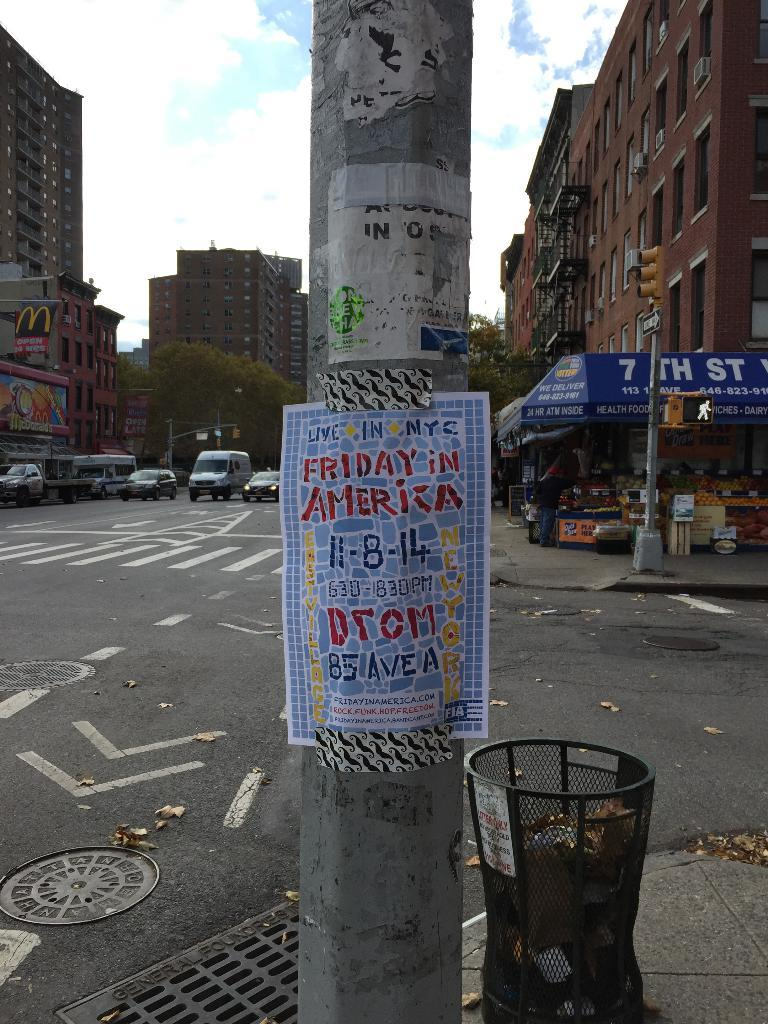<image>
Describe the image concisely. A poster is taped to a street pole that is advertising Friday in America. 